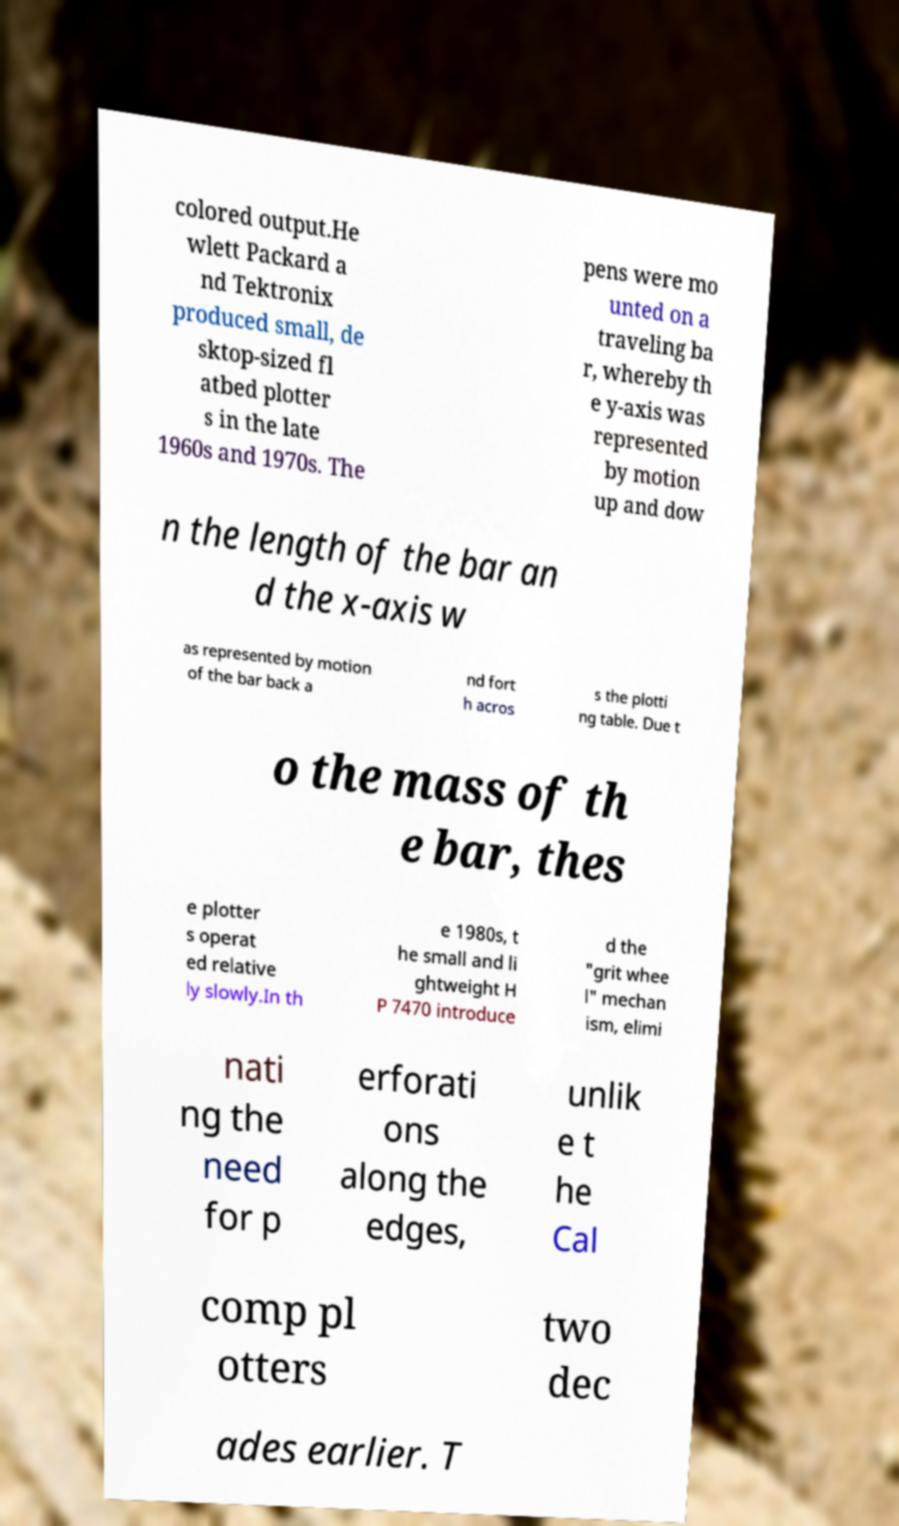Can you accurately transcribe the text from the provided image for me? colored output.He wlett Packard a nd Tektronix produced small, de sktop-sized fl atbed plotter s in the late 1960s and 1970s. The pens were mo unted on a traveling ba r, whereby th e y-axis was represented by motion up and dow n the length of the bar an d the x-axis w as represented by motion of the bar back a nd fort h acros s the plotti ng table. Due t o the mass of th e bar, thes e plotter s operat ed relative ly slowly.In th e 1980s, t he small and li ghtweight H P 7470 introduce d the "grit whee l" mechan ism, elimi nati ng the need for p erforati ons along the edges, unlik e t he Cal comp pl otters two dec ades earlier. T 